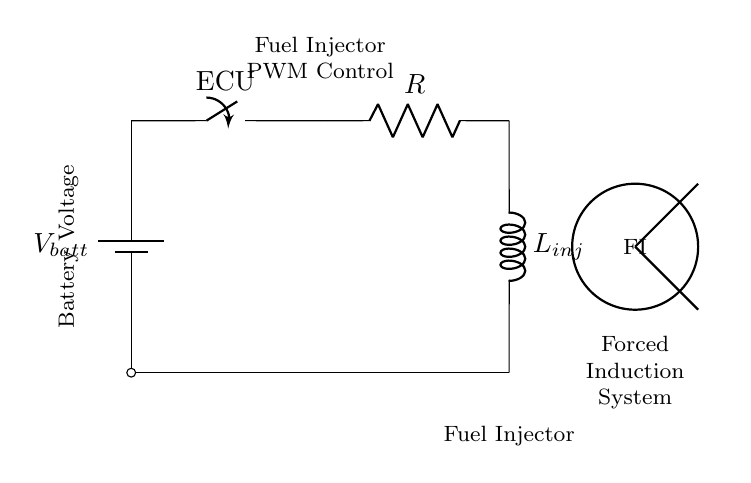What is the component type represented as L in the circuit? The component labeled as L is an inductor, which is represented by the symbol L in electrical diagrams. Inductors are commonly used in fuel injection systems to manage pulse width modulation.
Answer: Inductor What does R stand for in this RL circuit? The letter R in the circuit diagram stands for a resistor, which is used to limit the current flowing through the circuit. Resistors are key for controlling voltage drops and current levels in circuits.
Answer: Resistor What is the function of the ECU in this circuit? The ECU, represented as a switch in this diagram, controls the on-off operation of the circuit, determining when the fuel injector receives power to operate. This is crucial for managing fuel delivery in forced induction systems.
Answer: Switch What does the battery supply in this circuit? The battery supplies the voltage necessary to power the entire circuit, providing the energy needed for the ECU, resistor, and inductor to function together in controlling the fuel injector.
Answer: Voltage How does the inductor influence the fuel injector's operation? The inductor affects the timing of the current flowing to the fuel injector due to its property of resisting changes in current. This means that when the ECU activates the circuit, the inductor helps smooth out the power delivery, allowing for precise control of fuel injection timing and duration.
Answer: Timing What type of current does this RL circuit primarily manage for a fuel injector? This RL circuit primarily manages pulsed direct current for the fuel injector, as the ECU switches the current on and off to control the duration of fuel injection. PWM signals are typically used in such applications to optimize performance.
Answer: Pulsed direct current How is the forced induction system symbolized in this diagram? The forced induction system is represented by a thick circle in the circuit diagram, indicating its significance within the system. It correlates to where the fuel injector would apply the injected fuel to enhance engine performance under forced induction.
Answer: Circle 